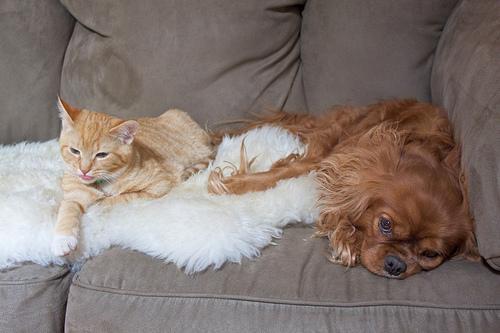How many paws do you see?
Give a very brief answer. 3. How many animals are alive?
Give a very brief answer. 2. How many people are wearing blue hats?
Give a very brief answer. 0. 